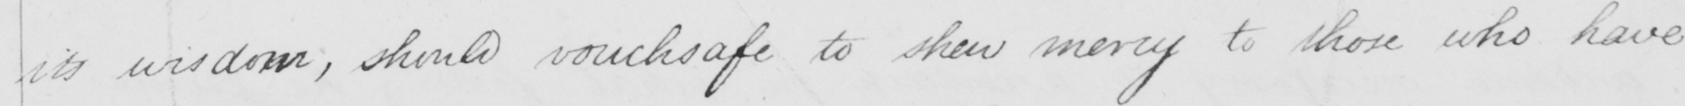Please transcribe the handwritten text in this image. its wisdom  , should vouchsafe to shew mercy to those who have 